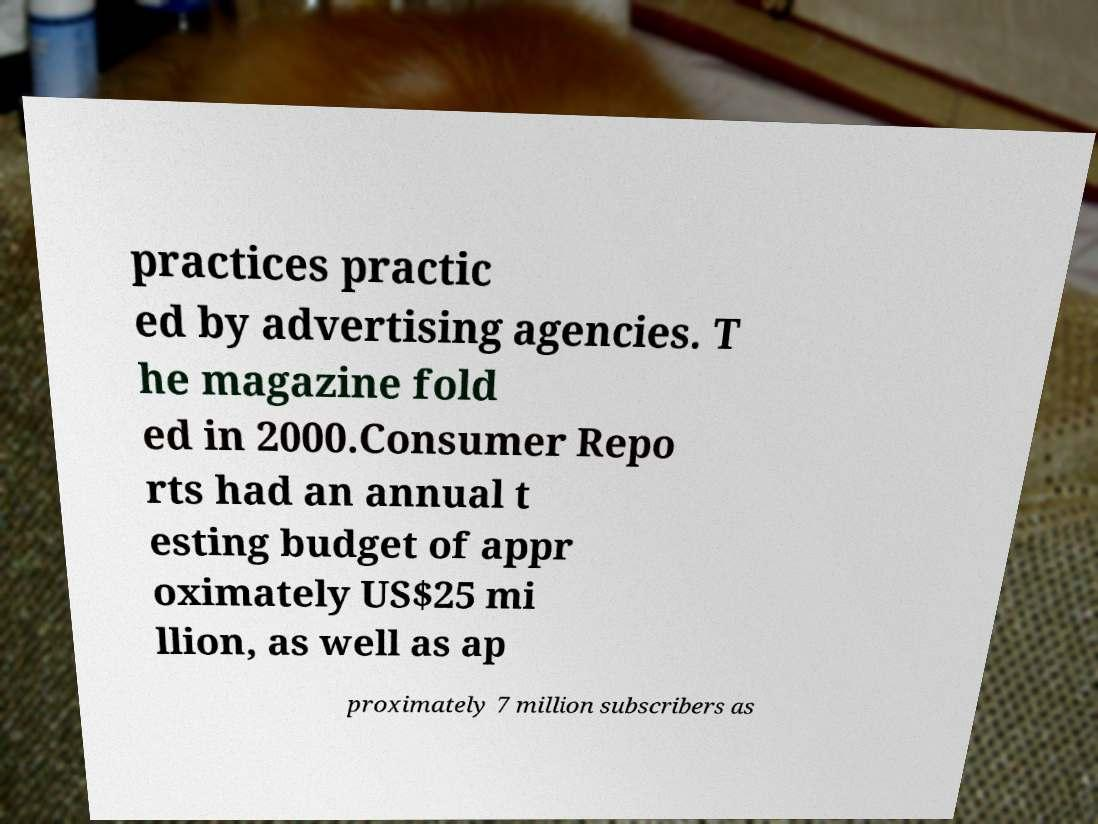Can you accurately transcribe the text from the provided image for me? practices practic ed by advertising agencies. T he magazine fold ed in 2000.Consumer Repo rts had an annual t esting budget of appr oximately US$25 mi llion, as well as ap proximately 7 million subscribers as 